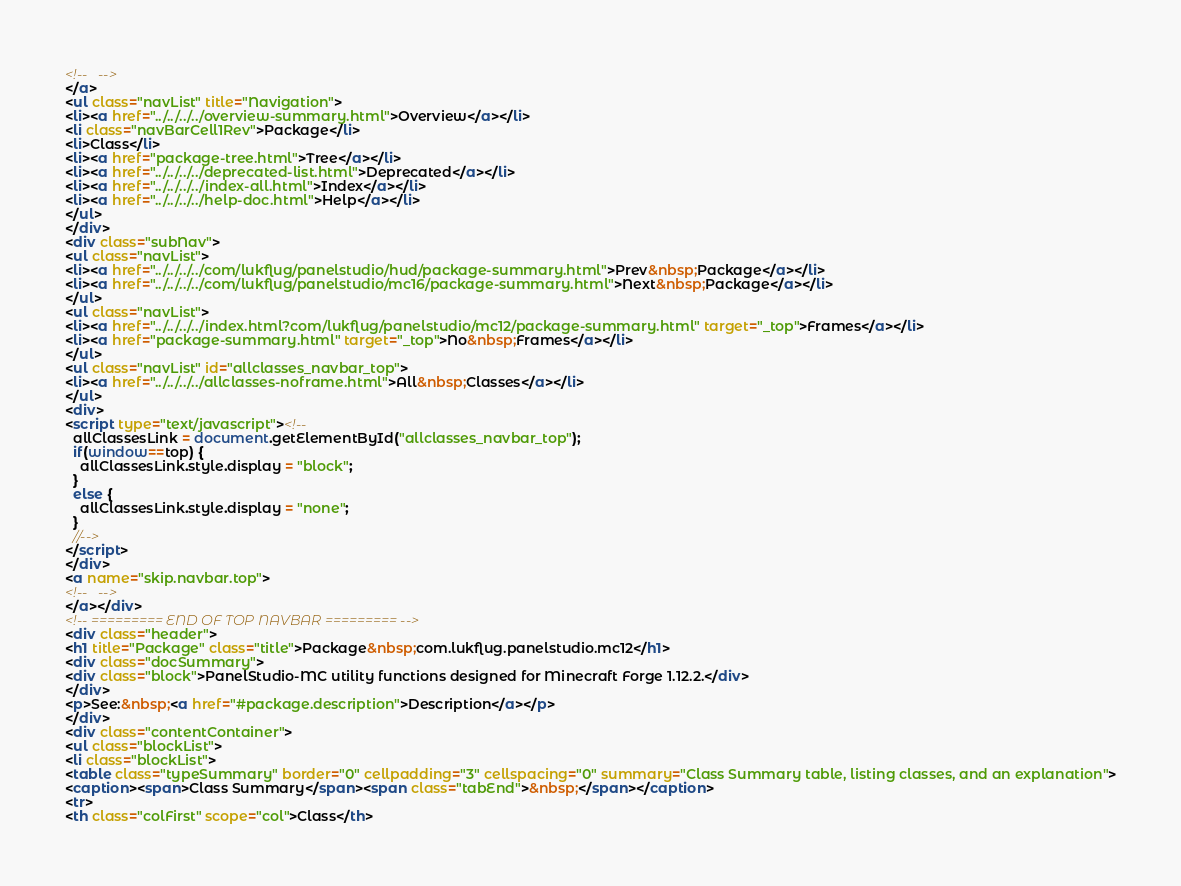<code> <loc_0><loc_0><loc_500><loc_500><_HTML_><!--   -->
</a>
<ul class="navList" title="Navigation">
<li><a href="../../../../overview-summary.html">Overview</a></li>
<li class="navBarCell1Rev">Package</li>
<li>Class</li>
<li><a href="package-tree.html">Tree</a></li>
<li><a href="../../../../deprecated-list.html">Deprecated</a></li>
<li><a href="../../../../index-all.html">Index</a></li>
<li><a href="../../../../help-doc.html">Help</a></li>
</ul>
</div>
<div class="subNav">
<ul class="navList">
<li><a href="../../../../com/lukflug/panelstudio/hud/package-summary.html">Prev&nbsp;Package</a></li>
<li><a href="../../../../com/lukflug/panelstudio/mc16/package-summary.html">Next&nbsp;Package</a></li>
</ul>
<ul class="navList">
<li><a href="../../../../index.html?com/lukflug/panelstudio/mc12/package-summary.html" target="_top">Frames</a></li>
<li><a href="package-summary.html" target="_top">No&nbsp;Frames</a></li>
</ul>
<ul class="navList" id="allclasses_navbar_top">
<li><a href="../../../../allclasses-noframe.html">All&nbsp;Classes</a></li>
</ul>
<div>
<script type="text/javascript"><!--
  allClassesLink = document.getElementById("allclasses_navbar_top");
  if(window==top) {
    allClassesLink.style.display = "block";
  }
  else {
    allClassesLink.style.display = "none";
  }
  //-->
</script>
</div>
<a name="skip.navbar.top">
<!--   -->
</a></div>
<!-- ========= END OF TOP NAVBAR ========= -->
<div class="header">
<h1 title="Package" class="title">Package&nbsp;com.lukflug.panelstudio.mc12</h1>
<div class="docSummary">
<div class="block">PanelStudio-MC utility functions designed for Minecraft Forge 1.12.2.</div>
</div>
<p>See:&nbsp;<a href="#package.description">Description</a></p>
</div>
<div class="contentContainer">
<ul class="blockList">
<li class="blockList">
<table class="typeSummary" border="0" cellpadding="3" cellspacing="0" summary="Class Summary table, listing classes, and an explanation">
<caption><span>Class Summary</span><span class="tabEnd">&nbsp;</span></caption>
<tr>
<th class="colFirst" scope="col">Class</th></code> 